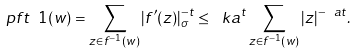<formula> <loc_0><loc_0><loc_500><loc_500>\ p f t \ 1 ( w ) = \sum _ { z \in f ^ { - 1 } ( w ) } | f ^ { \prime } ( z ) | _ { \sigma } ^ { - t } \leq \ k a ^ { t } \sum _ { z \in f ^ { - 1 } ( w ) } | z | ^ { - \ a t } .</formula> 